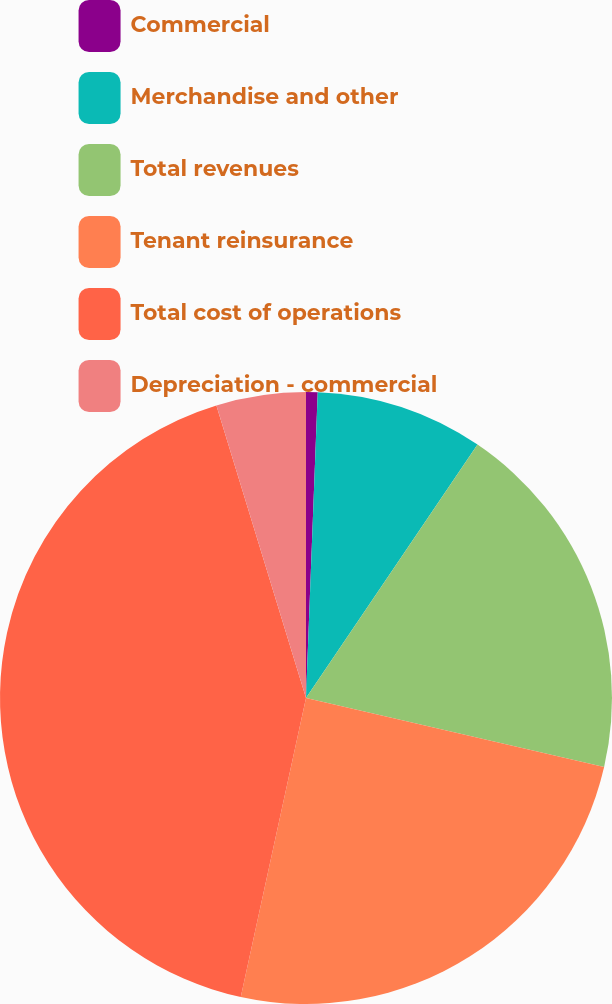<chart> <loc_0><loc_0><loc_500><loc_500><pie_chart><fcel>Commercial<fcel>Merchandise and other<fcel>Total revenues<fcel>Tenant reinsurance<fcel>Total cost of operations<fcel>Depreciation - commercial<nl><fcel>0.61%<fcel>8.86%<fcel>19.15%<fcel>24.8%<fcel>41.85%<fcel>4.73%<nl></chart> 